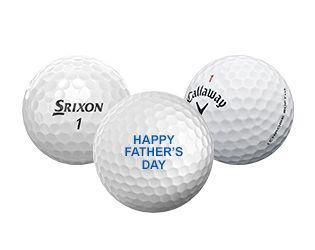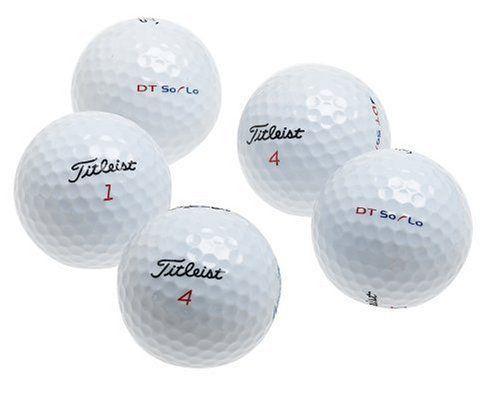The first image is the image on the left, the second image is the image on the right. For the images displayed, is the sentence "At least one image contains a single whole golf ball." factually correct? Answer yes or no. No. 